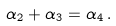<formula> <loc_0><loc_0><loc_500><loc_500>\alpha _ { 2 } + \alpha _ { 3 } = \alpha _ { 4 } \, .</formula> 